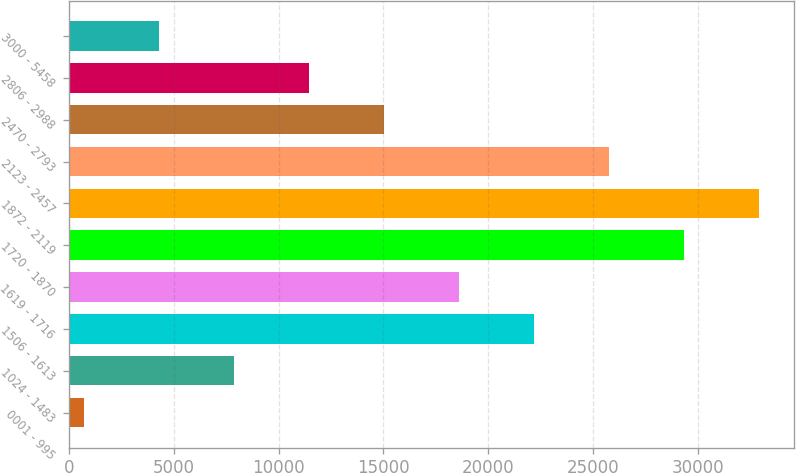<chart> <loc_0><loc_0><loc_500><loc_500><bar_chart><fcel>0001 - 995<fcel>1024 - 1483<fcel>1506 - 1613<fcel>1619 - 1716<fcel>1720 - 1870<fcel>1872 - 2119<fcel>2123 - 2457<fcel>2470 - 2793<fcel>2806 - 2988<fcel>3000 - 5458<nl><fcel>721<fcel>7875<fcel>22183<fcel>18606<fcel>29337<fcel>32914<fcel>25760<fcel>15029<fcel>11452<fcel>4298<nl></chart> 